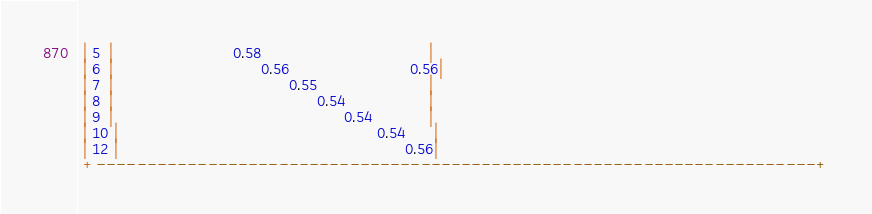Convert code to text. <code><loc_0><loc_0><loc_500><loc_500><_SQL_> | 5  |                          0.58                                    |
 | 6  |                                0.56                          0.56|
 | 7  |                                      0.55                        |
 | 8  |                                            0.54                  |
 | 9  |                                                  0.54            |
 | 10 |                                                        0.54      |
 | 12 |                                                              0.56|
 +-----------------------------------------------------------------------+
</code> 